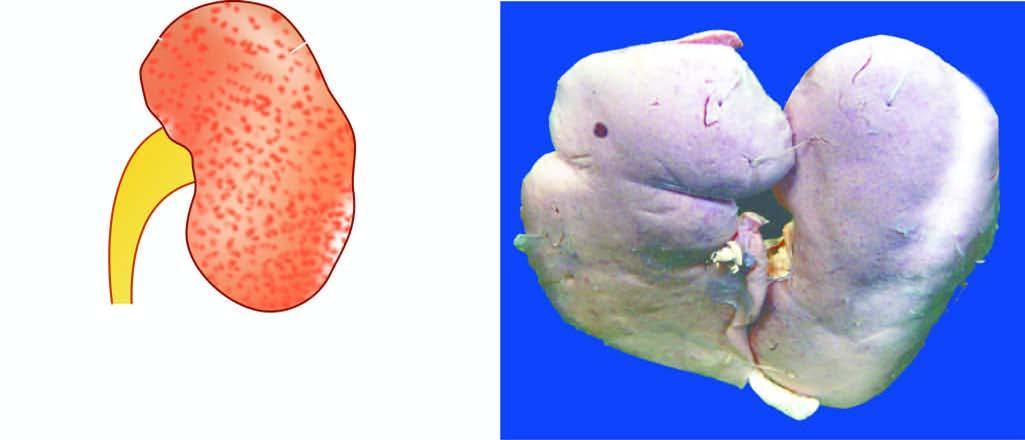what is in chronic hypertension benign nephrosclerosis?
Answer the question using a single word or phrase. Small contracted kidney 